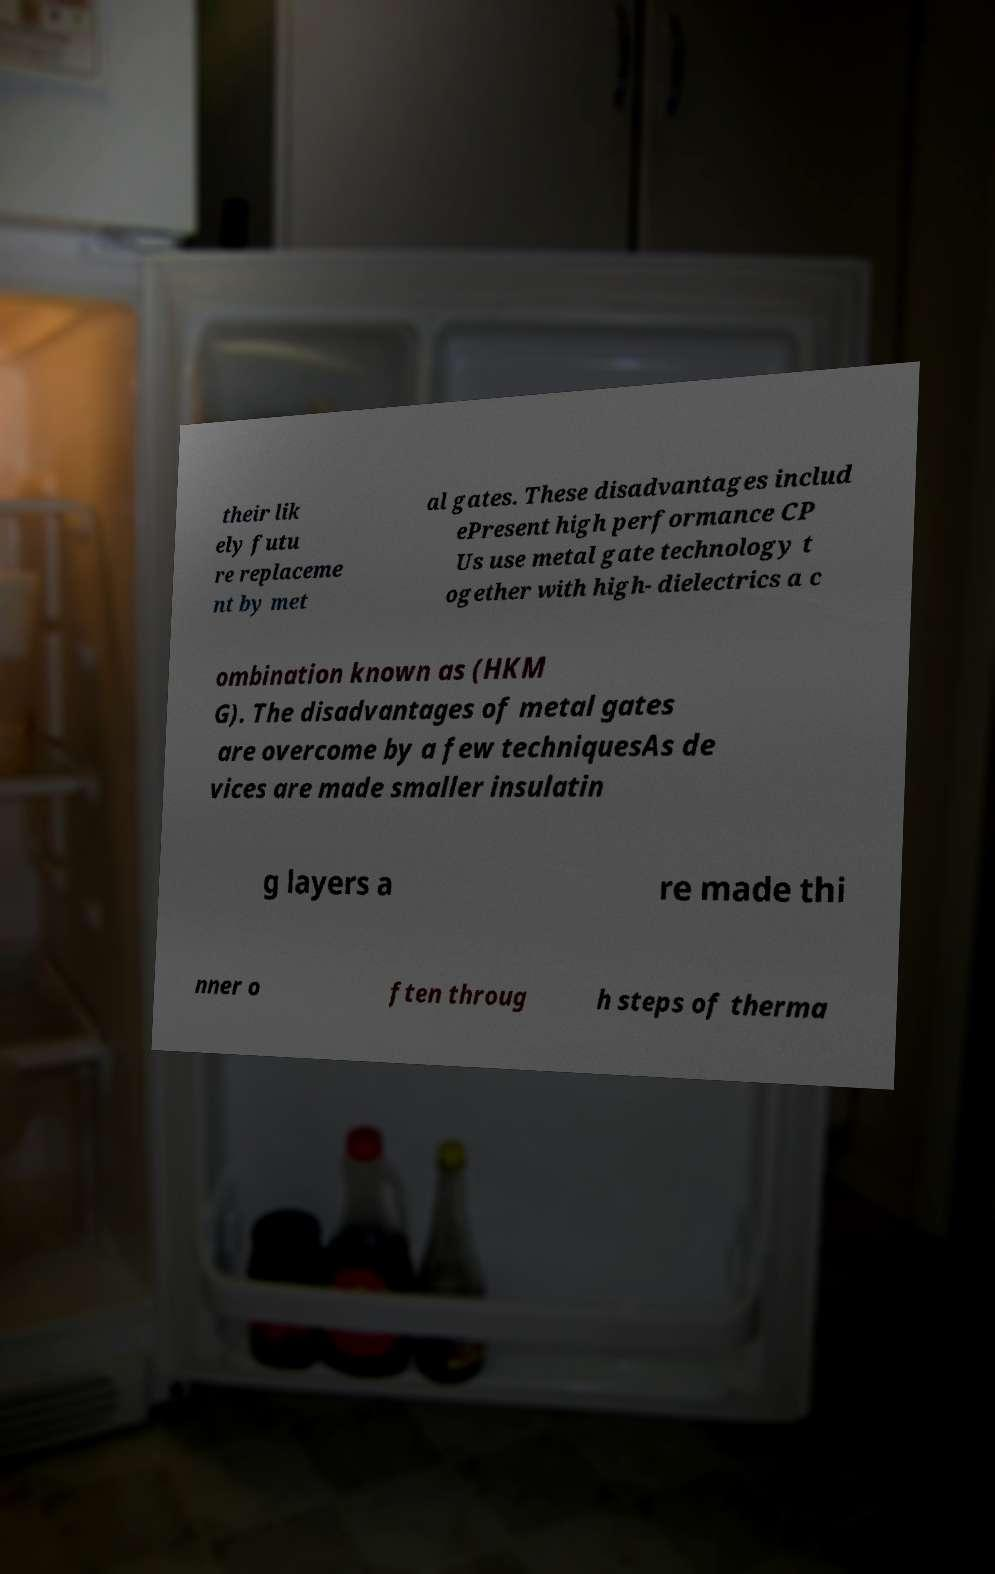Please read and relay the text visible in this image. What does it say? their lik ely futu re replaceme nt by met al gates. These disadvantages includ ePresent high performance CP Us use metal gate technology t ogether with high- dielectrics a c ombination known as (HKM G). The disadvantages of metal gates are overcome by a few techniquesAs de vices are made smaller insulatin g layers a re made thi nner o ften throug h steps of therma 